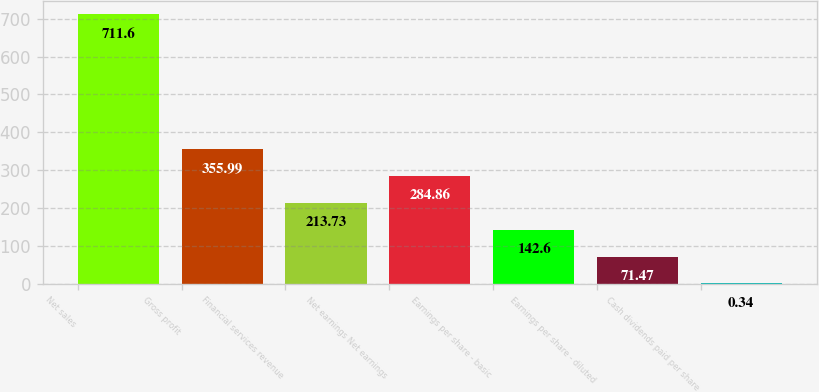<chart> <loc_0><loc_0><loc_500><loc_500><bar_chart><fcel>Net sales<fcel>Gross profit<fcel>Financial services revenue<fcel>Net earnings Net earnings<fcel>Earnings per share - basic<fcel>Earnings per share - diluted<fcel>Cash dividends paid per share<nl><fcel>711.6<fcel>355.99<fcel>213.73<fcel>284.86<fcel>142.6<fcel>71.47<fcel>0.34<nl></chart> 